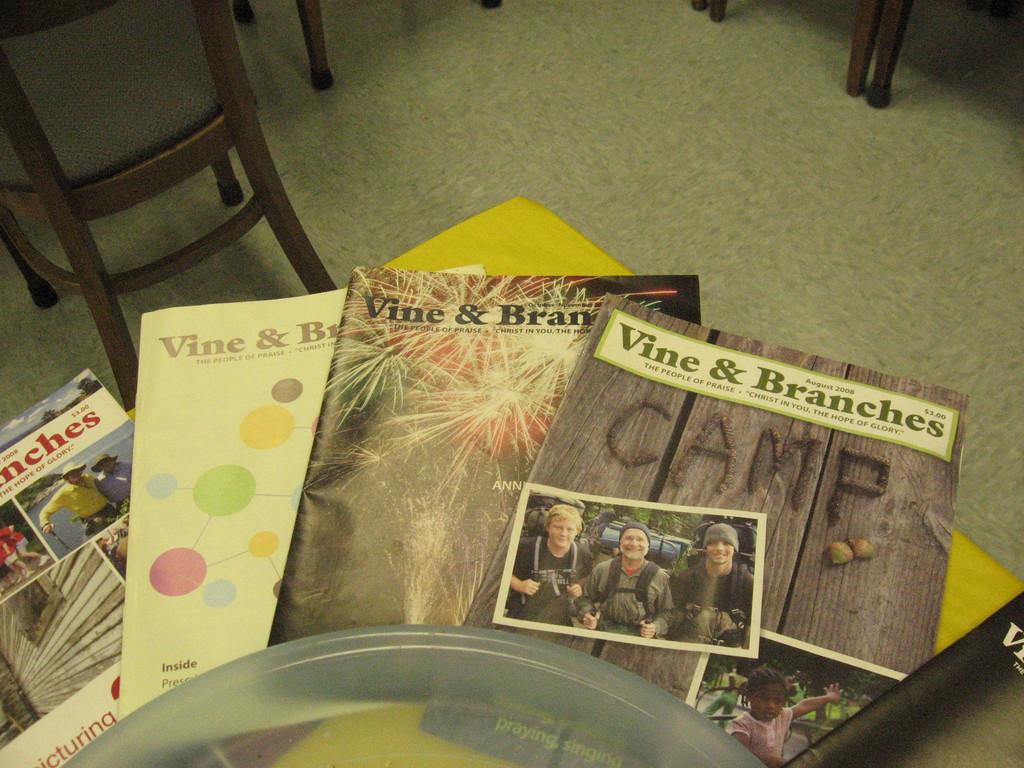<image>
Summarize the visual content of the image. Books laying on the floor about vine and branches 